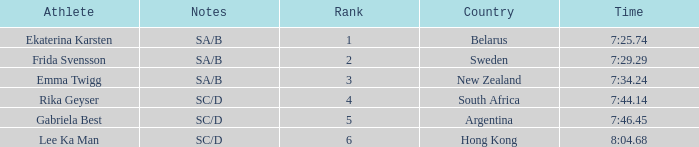What is the race time for emma twigg? 7:34.24. 